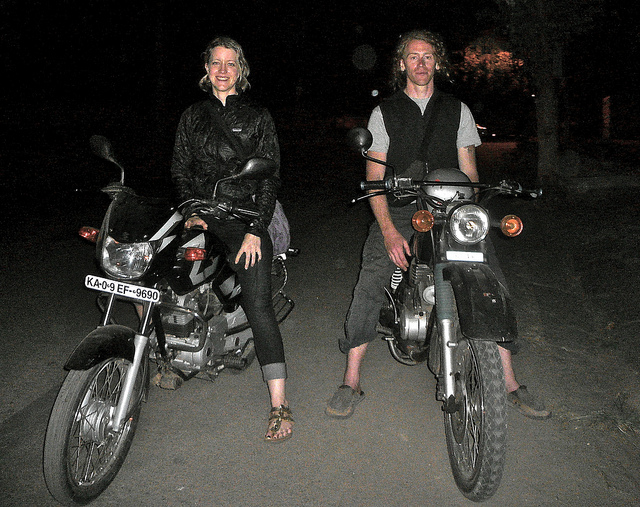Can you tell what kind of activity they might be doing? It seems like they are either starting or finishing a motorcycle ride. The casual attire and relaxed postures suggest they are engaging in a leisure activity, possibly exploring the local area or enjoying a night ride. 